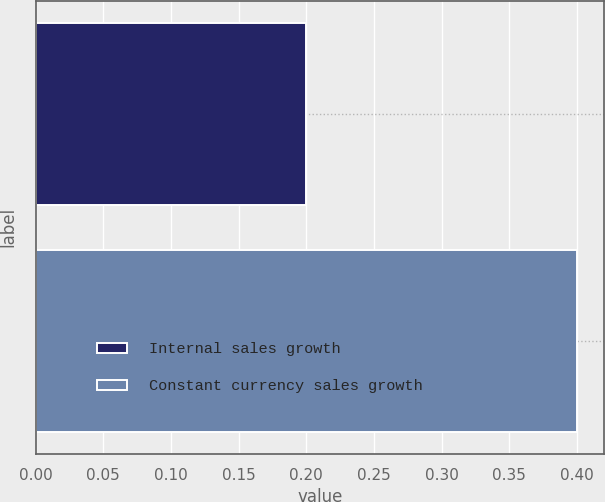Convert chart. <chart><loc_0><loc_0><loc_500><loc_500><bar_chart><fcel>Internal sales growth<fcel>Constant currency sales growth<nl><fcel>0.2<fcel>0.4<nl></chart> 